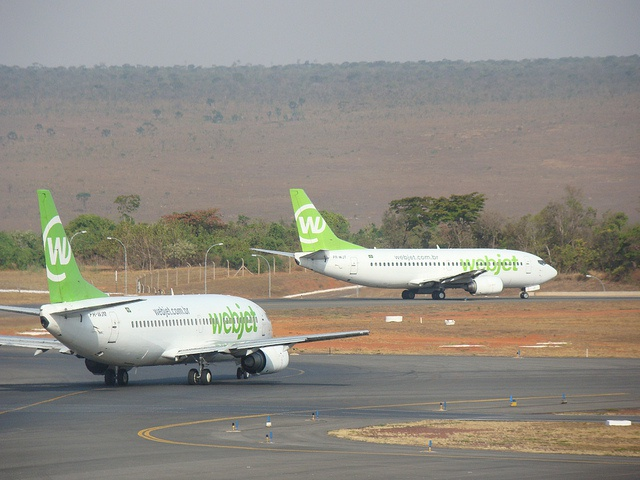Describe the objects in this image and their specific colors. I can see airplane in darkgray, lightgray, gray, and black tones and airplane in darkgray, ivory, lightgreen, and gray tones in this image. 